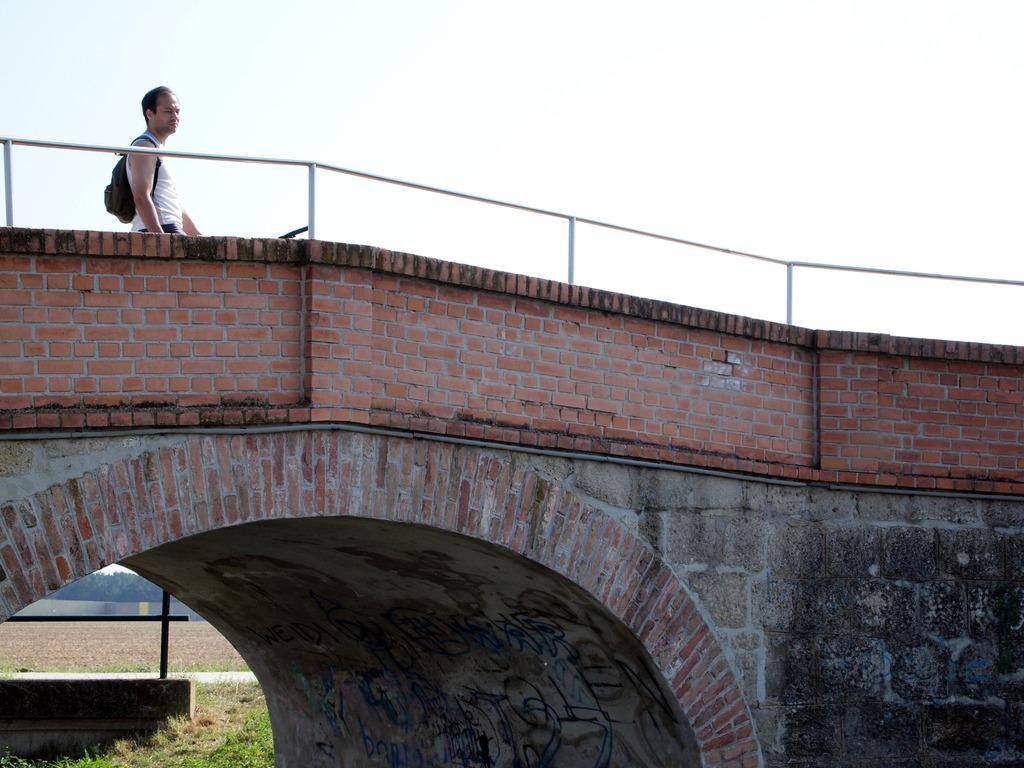What structure is present in the image? There is a bridge in the image. Can you describe the person in the image? There is a person standing with a backpack in the image. What materials are visible in the image? There are iron rods in the image. What type of vegetation is present in the image? There is grass in the image. What natural element is present in the image? There is water in the image. What other natural elements can be seen in the image? There are trees in the image. What is visible in the background of the image? The sky is visible in the background of the image. How many dogs are present in the image? There are no dogs present in the image. How many girls are visible in the image? There are no girls visible in the image. 